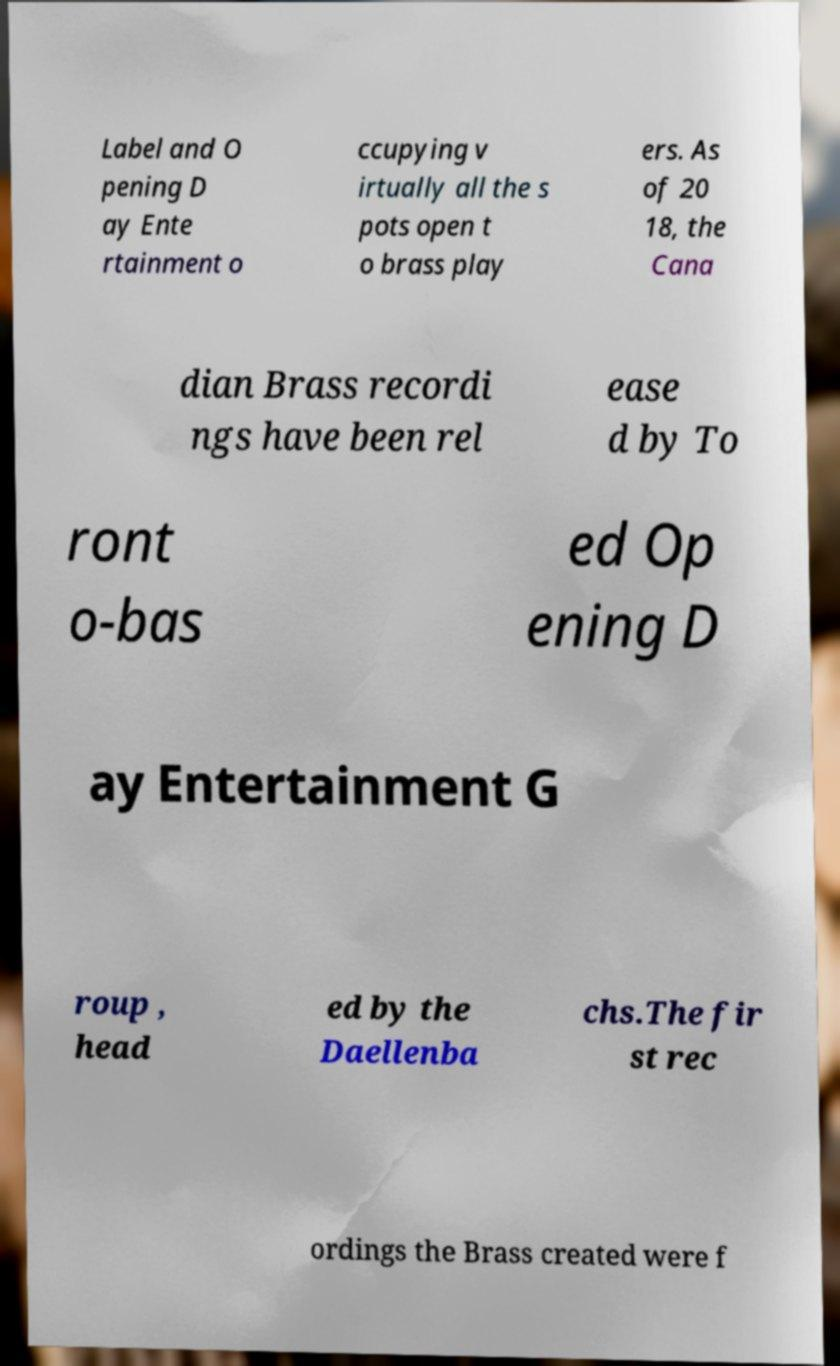There's text embedded in this image that I need extracted. Can you transcribe it verbatim? Label and O pening D ay Ente rtainment o ccupying v irtually all the s pots open t o brass play ers. As of 20 18, the Cana dian Brass recordi ngs have been rel ease d by To ront o-bas ed Op ening D ay Entertainment G roup , head ed by the Daellenba chs.The fir st rec ordings the Brass created were f 